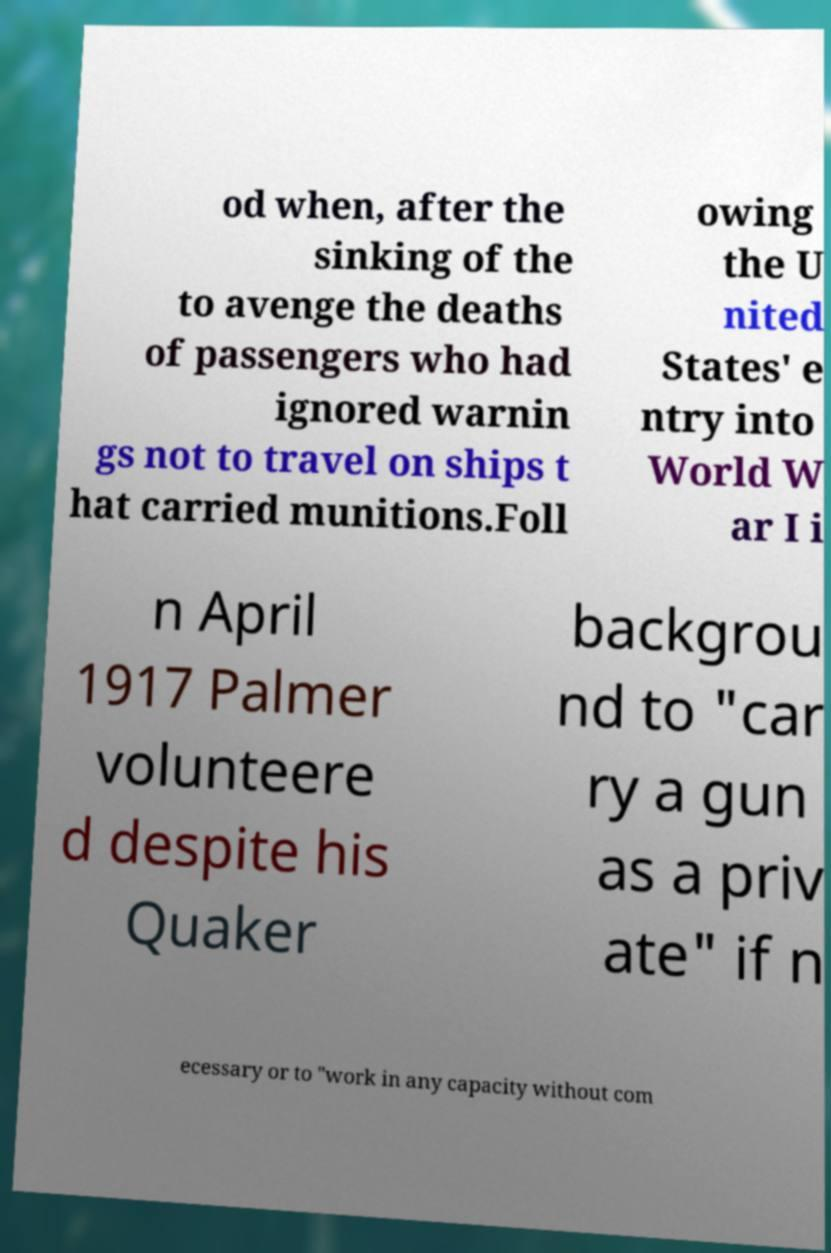Could you assist in decoding the text presented in this image and type it out clearly? od when, after the sinking of the to avenge the deaths of passengers who had ignored warnin gs not to travel on ships t hat carried munitions.Foll owing the U nited States' e ntry into World W ar I i n April 1917 Palmer volunteere d despite his Quaker backgrou nd to "car ry a gun as a priv ate" if n ecessary or to "work in any capacity without com 